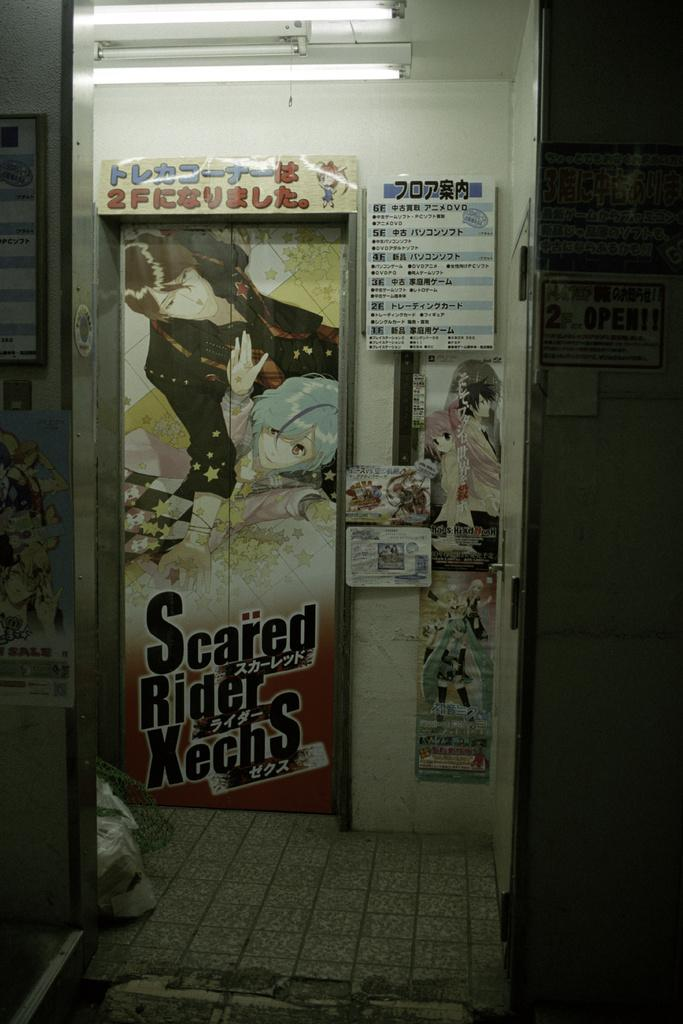What type of structure can be seen in the image? There is a wall in the image. Are there any openings in the wall? Yes, there is a door in the image. What can be found on the wall? There are posters in the image. What is visible on the rooftop? There are lights on a rooftop in the image. What other objects can be seen in the image? There are boards in the image. Where might this image have been taken? The image may have been taken in a room. How many planes are visible in the image? There are no planes visible in the image. What wish does the table fulfill in the image? There is no table present in the image, so it cannot fulfill any wishes. 